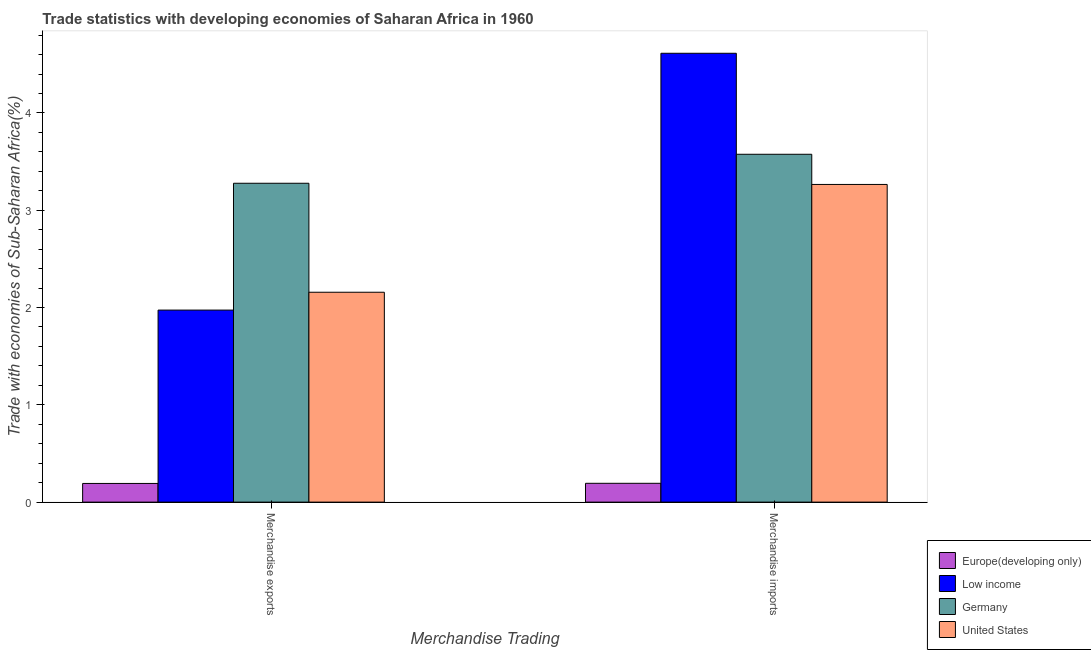Are the number of bars per tick equal to the number of legend labels?
Provide a succinct answer. Yes. What is the label of the 1st group of bars from the left?
Your answer should be very brief. Merchandise exports. What is the merchandise exports in Germany?
Offer a terse response. 3.28. Across all countries, what is the maximum merchandise exports?
Your answer should be compact. 3.28. Across all countries, what is the minimum merchandise exports?
Your response must be concise. 0.19. In which country was the merchandise imports maximum?
Give a very brief answer. Low income. In which country was the merchandise exports minimum?
Keep it short and to the point. Europe(developing only). What is the total merchandise imports in the graph?
Offer a very short reply. 11.65. What is the difference between the merchandise exports in Europe(developing only) and that in Germany?
Your response must be concise. -3.09. What is the difference between the merchandise exports in Low income and the merchandise imports in Europe(developing only)?
Your answer should be compact. 1.78. What is the average merchandise imports per country?
Ensure brevity in your answer.  2.91. What is the difference between the merchandise exports and merchandise imports in United States?
Offer a terse response. -1.11. In how many countries, is the merchandise imports greater than 0.4 %?
Provide a short and direct response. 3. What is the ratio of the merchandise imports in United States to that in Germany?
Your answer should be compact. 0.91. In how many countries, is the merchandise imports greater than the average merchandise imports taken over all countries?
Your answer should be very brief. 3. How many bars are there?
Offer a very short reply. 8. Are all the bars in the graph horizontal?
Your answer should be very brief. No. Are the values on the major ticks of Y-axis written in scientific E-notation?
Give a very brief answer. No. Does the graph contain any zero values?
Offer a terse response. No. Does the graph contain grids?
Give a very brief answer. No. Where does the legend appear in the graph?
Offer a terse response. Bottom right. What is the title of the graph?
Keep it short and to the point. Trade statistics with developing economies of Saharan Africa in 1960. What is the label or title of the X-axis?
Your answer should be very brief. Merchandise Trading. What is the label or title of the Y-axis?
Make the answer very short. Trade with economies of Sub-Saharan Africa(%). What is the Trade with economies of Sub-Saharan Africa(%) of Europe(developing only) in Merchandise exports?
Your response must be concise. 0.19. What is the Trade with economies of Sub-Saharan Africa(%) of Low income in Merchandise exports?
Ensure brevity in your answer.  1.97. What is the Trade with economies of Sub-Saharan Africa(%) in Germany in Merchandise exports?
Your response must be concise. 3.28. What is the Trade with economies of Sub-Saharan Africa(%) of United States in Merchandise exports?
Keep it short and to the point. 2.16. What is the Trade with economies of Sub-Saharan Africa(%) in Europe(developing only) in Merchandise imports?
Keep it short and to the point. 0.19. What is the Trade with economies of Sub-Saharan Africa(%) in Low income in Merchandise imports?
Your answer should be compact. 4.61. What is the Trade with economies of Sub-Saharan Africa(%) of Germany in Merchandise imports?
Provide a succinct answer. 3.58. What is the Trade with economies of Sub-Saharan Africa(%) in United States in Merchandise imports?
Your answer should be very brief. 3.27. Across all Merchandise Trading, what is the maximum Trade with economies of Sub-Saharan Africa(%) of Europe(developing only)?
Make the answer very short. 0.19. Across all Merchandise Trading, what is the maximum Trade with economies of Sub-Saharan Africa(%) in Low income?
Your answer should be very brief. 4.61. Across all Merchandise Trading, what is the maximum Trade with economies of Sub-Saharan Africa(%) in Germany?
Provide a short and direct response. 3.58. Across all Merchandise Trading, what is the maximum Trade with economies of Sub-Saharan Africa(%) in United States?
Offer a terse response. 3.27. Across all Merchandise Trading, what is the minimum Trade with economies of Sub-Saharan Africa(%) in Europe(developing only)?
Offer a very short reply. 0.19. Across all Merchandise Trading, what is the minimum Trade with economies of Sub-Saharan Africa(%) of Low income?
Your answer should be compact. 1.97. Across all Merchandise Trading, what is the minimum Trade with economies of Sub-Saharan Africa(%) in Germany?
Provide a short and direct response. 3.28. Across all Merchandise Trading, what is the minimum Trade with economies of Sub-Saharan Africa(%) of United States?
Ensure brevity in your answer.  2.16. What is the total Trade with economies of Sub-Saharan Africa(%) of Europe(developing only) in the graph?
Your response must be concise. 0.39. What is the total Trade with economies of Sub-Saharan Africa(%) of Low income in the graph?
Keep it short and to the point. 6.59. What is the total Trade with economies of Sub-Saharan Africa(%) of Germany in the graph?
Your answer should be very brief. 6.85. What is the total Trade with economies of Sub-Saharan Africa(%) in United States in the graph?
Provide a short and direct response. 5.42. What is the difference between the Trade with economies of Sub-Saharan Africa(%) of Europe(developing only) in Merchandise exports and that in Merchandise imports?
Keep it short and to the point. -0. What is the difference between the Trade with economies of Sub-Saharan Africa(%) in Low income in Merchandise exports and that in Merchandise imports?
Ensure brevity in your answer.  -2.64. What is the difference between the Trade with economies of Sub-Saharan Africa(%) in Germany in Merchandise exports and that in Merchandise imports?
Ensure brevity in your answer.  -0.3. What is the difference between the Trade with economies of Sub-Saharan Africa(%) in United States in Merchandise exports and that in Merchandise imports?
Give a very brief answer. -1.11. What is the difference between the Trade with economies of Sub-Saharan Africa(%) in Europe(developing only) in Merchandise exports and the Trade with economies of Sub-Saharan Africa(%) in Low income in Merchandise imports?
Provide a succinct answer. -4.42. What is the difference between the Trade with economies of Sub-Saharan Africa(%) in Europe(developing only) in Merchandise exports and the Trade with economies of Sub-Saharan Africa(%) in Germany in Merchandise imports?
Your response must be concise. -3.38. What is the difference between the Trade with economies of Sub-Saharan Africa(%) of Europe(developing only) in Merchandise exports and the Trade with economies of Sub-Saharan Africa(%) of United States in Merchandise imports?
Your answer should be very brief. -3.07. What is the difference between the Trade with economies of Sub-Saharan Africa(%) of Low income in Merchandise exports and the Trade with economies of Sub-Saharan Africa(%) of Germany in Merchandise imports?
Keep it short and to the point. -1.6. What is the difference between the Trade with economies of Sub-Saharan Africa(%) in Low income in Merchandise exports and the Trade with economies of Sub-Saharan Africa(%) in United States in Merchandise imports?
Your answer should be compact. -1.29. What is the difference between the Trade with economies of Sub-Saharan Africa(%) of Germany in Merchandise exports and the Trade with economies of Sub-Saharan Africa(%) of United States in Merchandise imports?
Provide a succinct answer. 0.01. What is the average Trade with economies of Sub-Saharan Africa(%) in Europe(developing only) per Merchandise Trading?
Offer a very short reply. 0.19. What is the average Trade with economies of Sub-Saharan Africa(%) in Low income per Merchandise Trading?
Your answer should be very brief. 3.29. What is the average Trade with economies of Sub-Saharan Africa(%) of Germany per Merchandise Trading?
Provide a short and direct response. 3.43. What is the average Trade with economies of Sub-Saharan Africa(%) of United States per Merchandise Trading?
Your response must be concise. 2.71. What is the difference between the Trade with economies of Sub-Saharan Africa(%) in Europe(developing only) and Trade with economies of Sub-Saharan Africa(%) in Low income in Merchandise exports?
Offer a very short reply. -1.78. What is the difference between the Trade with economies of Sub-Saharan Africa(%) of Europe(developing only) and Trade with economies of Sub-Saharan Africa(%) of Germany in Merchandise exports?
Make the answer very short. -3.09. What is the difference between the Trade with economies of Sub-Saharan Africa(%) in Europe(developing only) and Trade with economies of Sub-Saharan Africa(%) in United States in Merchandise exports?
Provide a short and direct response. -1.97. What is the difference between the Trade with economies of Sub-Saharan Africa(%) of Low income and Trade with economies of Sub-Saharan Africa(%) of Germany in Merchandise exports?
Offer a terse response. -1.3. What is the difference between the Trade with economies of Sub-Saharan Africa(%) in Low income and Trade with economies of Sub-Saharan Africa(%) in United States in Merchandise exports?
Give a very brief answer. -0.18. What is the difference between the Trade with economies of Sub-Saharan Africa(%) of Germany and Trade with economies of Sub-Saharan Africa(%) of United States in Merchandise exports?
Your answer should be very brief. 1.12. What is the difference between the Trade with economies of Sub-Saharan Africa(%) in Europe(developing only) and Trade with economies of Sub-Saharan Africa(%) in Low income in Merchandise imports?
Keep it short and to the point. -4.42. What is the difference between the Trade with economies of Sub-Saharan Africa(%) of Europe(developing only) and Trade with economies of Sub-Saharan Africa(%) of Germany in Merchandise imports?
Provide a short and direct response. -3.38. What is the difference between the Trade with economies of Sub-Saharan Africa(%) in Europe(developing only) and Trade with economies of Sub-Saharan Africa(%) in United States in Merchandise imports?
Your answer should be compact. -3.07. What is the difference between the Trade with economies of Sub-Saharan Africa(%) of Low income and Trade with economies of Sub-Saharan Africa(%) of Germany in Merchandise imports?
Your answer should be compact. 1.04. What is the difference between the Trade with economies of Sub-Saharan Africa(%) of Low income and Trade with economies of Sub-Saharan Africa(%) of United States in Merchandise imports?
Your answer should be very brief. 1.35. What is the difference between the Trade with economies of Sub-Saharan Africa(%) in Germany and Trade with economies of Sub-Saharan Africa(%) in United States in Merchandise imports?
Provide a succinct answer. 0.31. What is the ratio of the Trade with economies of Sub-Saharan Africa(%) in Low income in Merchandise exports to that in Merchandise imports?
Offer a very short reply. 0.43. What is the ratio of the Trade with economies of Sub-Saharan Africa(%) of Germany in Merchandise exports to that in Merchandise imports?
Provide a short and direct response. 0.92. What is the ratio of the Trade with economies of Sub-Saharan Africa(%) of United States in Merchandise exports to that in Merchandise imports?
Keep it short and to the point. 0.66. What is the difference between the highest and the second highest Trade with economies of Sub-Saharan Africa(%) of Europe(developing only)?
Your answer should be very brief. 0. What is the difference between the highest and the second highest Trade with economies of Sub-Saharan Africa(%) in Low income?
Your answer should be compact. 2.64. What is the difference between the highest and the second highest Trade with economies of Sub-Saharan Africa(%) in Germany?
Offer a terse response. 0.3. What is the difference between the highest and the second highest Trade with economies of Sub-Saharan Africa(%) of United States?
Provide a short and direct response. 1.11. What is the difference between the highest and the lowest Trade with economies of Sub-Saharan Africa(%) in Europe(developing only)?
Provide a succinct answer. 0. What is the difference between the highest and the lowest Trade with economies of Sub-Saharan Africa(%) in Low income?
Make the answer very short. 2.64. What is the difference between the highest and the lowest Trade with economies of Sub-Saharan Africa(%) in Germany?
Offer a terse response. 0.3. What is the difference between the highest and the lowest Trade with economies of Sub-Saharan Africa(%) of United States?
Offer a very short reply. 1.11. 